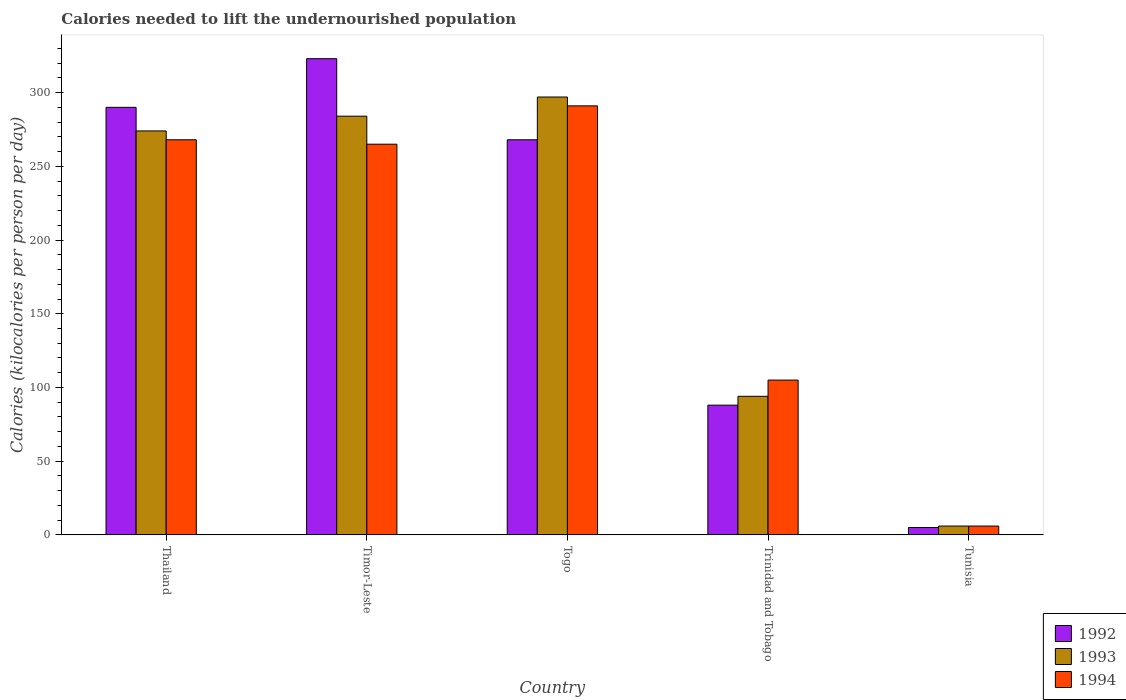How many different coloured bars are there?
Make the answer very short. 3. How many groups of bars are there?
Make the answer very short. 5. Are the number of bars per tick equal to the number of legend labels?
Make the answer very short. Yes. Are the number of bars on each tick of the X-axis equal?
Ensure brevity in your answer.  Yes. How many bars are there on the 5th tick from the right?
Keep it short and to the point. 3. What is the label of the 4th group of bars from the left?
Provide a succinct answer. Trinidad and Tobago. What is the total calories needed to lift the undernourished population in 1993 in Togo?
Give a very brief answer. 297. Across all countries, what is the maximum total calories needed to lift the undernourished population in 1993?
Provide a succinct answer. 297. Across all countries, what is the minimum total calories needed to lift the undernourished population in 1994?
Make the answer very short. 6. In which country was the total calories needed to lift the undernourished population in 1994 maximum?
Your answer should be compact. Togo. In which country was the total calories needed to lift the undernourished population in 1994 minimum?
Ensure brevity in your answer.  Tunisia. What is the total total calories needed to lift the undernourished population in 1993 in the graph?
Keep it short and to the point. 955. What is the difference between the total calories needed to lift the undernourished population in 1992 in Timor-Leste and that in Tunisia?
Your answer should be very brief. 318. What is the average total calories needed to lift the undernourished population in 1994 per country?
Offer a terse response. 187. What is the ratio of the total calories needed to lift the undernourished population in 1994 in Thailand to that in Timor-Leste?
Your answer should be compact. 1.01. Is the difference between the total calories needed to lift the undernourished population in 1992 in Thailand and Togo greater than the difference between the total calories needed to lift the undernourished population in 1993 in Thailand and Togo?
Offer a very short reply. Yes. What is the difference between the highest and the second highest total calories needed to lift the undernourished population in 1992?
Provide a short and direct response. -33. What is the difference between the highest and the lowest total calories needed to lift the undernourished population in 1993?
Ensure brevity in your answer.  291. In how many countries, is the total calories needed to lift the undernourished population in 1992 greater than the average total calories needed to lift the undernourished population in 1992 taken over all countries?
Your response must be concise. 3. Is the sum of the total calories needed to lift the undernourished population in 1993 in Thailand and Tunisia greater than the maximum total calories needed to lift the undernourished population in 1994 across all countries?
Your answer should be compact. No. What does the 3rd bar from the left in Thailand represents?
Offer a terse response. 1994. Is it the case that in every country, the sum of the total calories needed to lift the undernourished population in 1992 and total calories needed to lift the undernourished population in 1994 is greater than the total calories needed to lift the undernourished population in 1993?
Give a very brief answer. Yes. What is the difference between two consecutive major ticks on the Y-axis?
Ensure brevity in your answer.  50. Does the graph contain any zero values?
Your response must be concise. No. Does the graph contain grids?
Offer a very short reply. No. How are the legend labels stacked?
Offer a terse response. Vertical. What is the title of the graph?
Provide a succinct answer. Calories needed to lift the undernourished population. What is the label or title of the X-axis?
Offer a terse response. Country. What is the label or title of the Y-axis?
Make the answer very short. Calories (kilocalories per person per day). What is the Calories (kilocalories per person per day) in 1992 in Thailand?
Give a very brief answer. 290. What is the Calories (kilocalories per person per day) of 1993 in Thailand?
Ensure brevity in your answer.  274. What is the Calories (kilocalories per person per day) in 1994 in Thailand?
Provide a short and direct response. 268. What is the Calories (kilocalories per person per day) of 1992 in Timor-Leste?
Offer a very short reply. 323. What is the Calories (kilocalories per person per day) in 1993 in Timor-Leste?
Offer a very short reply. 284. What is the Calories (kilocalories per person per day) of 1994 in Timor-Leste?
Your response must be concise. 265. What is the Calories (kilocalories per person per day) in 1992 in Togo?
Your response must be concise. 268. What is the Calories (kilocalories per person per day) of 1993 in Togo?
Ensure brevity in your answer.  297. What is the Calories (kilocalories per person per day) in 1994 in Togo?
Keep it short and to the point. 291. What is the Calories (kilocalories per person per day) in 1993 in Trinidad and Tobago?
Ensure brevity in your answer.  94. What is the Calories (kilocalories per person per day) in 1994 in Trinidad and Tobago?
Ensure brevity in your answer.  105. What is the Calories (kilocalories per person per day) in 1992 in Tunisia?
Make the answer very short. 5. What is the Calories (kilocalories per person per day) of 1993 in Tunisia?
Give a very brief answer. 6. What is the Calories (kilocalories per person per day) in 1994 in Tunisia?
Offer a terse response. 6. Across all countries, what is the maximum Calories (kilocalories per person per day) of 1992?
Provide a short and direct response. 323. Across all countries, what is the maximum Calories (kilocalories per person per day) of 1993?
Offer a very short reply. 297. Across all countries, what is the maximum Calories (kilocalories per person per day) of 1994?
Provide a short and direct response. 291. Across all countries, what is the minimum Calories (kilocalories per person per day) of 1992?
Offer a terse response. 5. Across all countries, what is the minimum Calories (kilocalories per person per day) in 1993?
Keep it short and to the point. 6. What is the total Calories (kilocalories per person per day) of 1992 in the graph?
Your response must be concise. 974. What is the total Calories (kilocalories per person per day) of 1993 in the graph?
Offer a terse response. 955. What is the total Calories (kilocalories per person per day) in 1994 in the graph?
Keep it short and to the point. 935. What is the difference between the Calories (kilocalories per person per day) in 1992 in Thailand and that in Timor-Leste?
Keep it short and to the point. -33. What is the difference between the Calories (kilocalories per person per day) in 1992 in Thailand and that in Togo?
Provide a succinct answer. 22. What is the difference between the Calories (kilocalories per person per day) in 1993 in Thailand and that in Togo?
Offer a very short reply. -23. What is the difference between the Calories (kilocalories per person per day) in 1994 in Thailand and that in Togo?
Give a very brief answer. -23. What is the difference between the Calories (kilocalories per person per day) of 1992 in Thailand and that in Trinidad and Tobago?
Your answer should be very brief. 202. What is the difference between the Calories (kilocalories per person per day) in 1993 in Thailand and that in Trinidad and Tobago?
Keep it short and to the point. 180. What is the difference between the Calories (kilocalories per person per day) in 1994 in Thailand and that in Trinidad and Tobago?
Provide a short and direct response. 163. What is the difference between the Calories (kilocalories per person per day) in 1992 in Thailand and that in Tunisia?
Give a very brief answer. 285. What is the difference between the Calories (kilocalories per person per day) in 1993 in Thailand and that in Tunisia?
Your response must be concise. 268. What is the difference between the Calories (kilocalories per person per day) in 1994 in Thailand and that in Tunisia?
Your answer should be very brief. 262. What is the difference between the Calories (kilocalories per person per day) in 1993 in Timor-Leste and that in Togo?
Give a very brief answer. -13. What is the difference between the Calories (kilocalories per person per day) in 1994 in Timor-Leste and that in Togo?
Provide a succinct answer. -26. What is the difference between the Calories (kilocalories per person per day) of 1992 in Timor-Leste and that in Trinidad and Tobago?
Provide a succinct answer. 235. What is the difference between the Calories (kilocalories per person per day) of 1993 in Timor-Leste and that in Trinidad and Tobago?
Your answer should be compact. 190. What is the difference between the Calories (kilocalories per person per day) of 1994 in Timor-Leste and that in Trinidad and Tobago?
Ensure brevity in your answer.  160. What is the difference between the Calories (kilocalories per person per day) in 1992 in Timor-Leste and that in Tunisia?
Provide a succinct answer. 318. What is the difference between the Calories (kilocalories per person per day) of 1993 in Timor-Leste and that in Tunisia?
Provide a succinct answer. 278. What is the difference between the Calories (kilocalories per person per day) in 1994 in Timor-Leste and that in Tunisia?
Your response must be concise. 259. What is the difference between the Calories (kilocalories per person per day) of 1992 in Togo and that in Trinidad and Tobago?
Offer a very short reply. 180. What is the difference between the Calories (kilocalories per person per day) in 1993 in Togo and that in Trinidad and Tobago?
Provide a short and direct response. 203. What is the difference between the Calories (kilocalories per person per day) of 1994 in Togo and that in Trinidad and Tobago?
Your answer should be very brief. 186. What is the difference between the Calories (kilocalories per person per day) in 1992 in Togo and that in Tunisia?
Offer a very short reply. 263. What is the difference between the Calories (kilocalories per person per day) in 1993 in Togo and that in Tunisia?
Keep it short and to the point. 291. What is the difference between the Calories (kilocalories per person per day) of 1994 in Togo and that in Tunisia?
Your answer should be very brief. 285. What is the difference between the Calories (kilocalories per person per day) in 1992 in Trinidad and Tobago and that in Tunisia?
Give a very brief answer. 83. What is the difference between the Calories (kilocalories per person per day) of 1993 in Trinidad and Tobago and that in Tunisia?
Offer a very short reply. 88. What is the difference between the Calories (kilocalories per person per day) in 1994 in Trinidad and Tobago and that in Tunisia?
Give a very brief answer. 99. What is the difference between the Calories (kilocalories per person per day) in 1992 in Thailand and the Calories (kilocalories per person per day) in 1993 in Timor-Leste?
Your response must be concise. 6. What is the difference between the Calories (kilocalories per person per day) in 1993 in Thailand and the Calories (kilocalories per person per day) in 1994 in Timor-Leste?
Keep it short and to the point. 9. What is the difference between the Calories (kilocalories per person per day) of 1992 in Thailand and the Calories (kilocalories per person per day) of 1994 in Togo?
Keep it short and to the point. -1. What is the difference between the Calories (kilocalories per person per day) in 1992 in Thailand and the Calories (kilocalories per person per day) in 1993 in Trinidad and Tobago?
Give a very brief answer. 196. What is the difference between the Calories (kilocalories per person per day) of 1992 in Thailand and the Calories (kilocalories per person per day) of 1994 in Trinidad and Tobago?
Your response must be concise. 185. What is the difference between the Calories (kilocalories per person per day) in 1993 in Thailand and the Calories (kilocalories per person per day) in 1994 in Trinidad and Tobago?
Provide a short and direct response. 169. What is the difference between the Calories (kilocalories per person per day) in 1992 in Thailand and the Calories (kilocalories per person per day) in 1993 in Tunisia?
Ensure brevity in your answer.  284. What is the difference between the Calories (kilocalories per person per day) of 1992 in Thailand and the Calories (kilocalories per person per day) of 1994 in Tunisia?
Keep it short and to the point. 284. What is the difference between the Calories (kilocalories per person per day) in 1993 in Thailand and the Calories (kilocalories per person per day) in 1994 in Tunisia?
Your answer should be compact. 268. What is the difference between the Calories (kilocalories per person per day) of 1992 in Timor-Leste and the Calories (kilocalories per person per day) of 1993 in Togo?
Your answer should be compact. 26. What is the difference between the Calories (kilocalories per person per day) of 1992 in Timor-Leste and the Calories (kilocalories per person per day) of 1994 in Togo?
Your answer should be compact. 32. What is the difference between the Calories (kilocalories per person per day) of 1992 in Timor-Leste and the Calories (kilocalories per person per day) of 1993 in Trinidad and Tobago?
Your response must be concise. 229. What is the difference between the Calories (kilocalories per person per day) of 1992 in Timor-Leste and the Calories (kilocalories per person per day) of 1994 in Trinidad and Tobago?
Offer a very short reply. 218. What is the difference between the Calories (kilocalories per person per day) of 1993 in Timor-Leste and the Calories (kilocalories per person per day) of 1994 in Trinidad and Tobago?
Ensure brevity in your answer.  179. What is the difference between the Calories (kilocalories per person per day) in 1992 in Timor-Leste and the Calories (kilocalories per person per day) in 1993 in Tunisia?
Your response must be concise. 317. What is the difference between the Calories (kilocalories per person per day) of 1992 in Timor-Leste and the Calories (kilocalories per person per day) of 1994 in Tunisia?
Ensure brevity in your answer.  317. What is the difference between the Calories (kilocalories per person per day) of 1993 in Timor-Leste and the Calories (kilocalories per person per day) of 1994 in Tunisia?
Your answer should be compact. 278. What is the difference between the Calories (kilocalories per person per day) of 1992 in Togo and the Calories (kilocalories per person per day) of 1993 in Trinidad and Tobago?
Provide a succinct answer. 174. What is the difference between the Calories (kilocalories per person per day) of 1992 in Togo and the Calories (kilocalories per person per day) of 1994 in Trinidad and Tobago?
Provide a succinct answer. 163. What is the difference between the Calories (kilocalories per person per day) of 1993 in Togo and the Calories (kilocalories per person per day) of 1994 in Trinidad and Tobago?
Offer a very short reply. 192. What is the difference between the Calories (kilocalories per person per day) of 1992 in Togo and the Calories (kilocalories per person per day) of 1993 in Tunisia?
Provide a succinct answer. 262. What is the difference between the Calories (kilocalories per person per day) in 1992 in Togo and the Calories (kilocalories per person per day) in 1994 in Tunisia?
Make the answer very short. 262. What is the difference between the Calories (kilocalories per person per day) in 1993 in Togo and the Calories (kilocalories per person per day) in 1994 in Tunisia?
Your answer should be compact. 291. What is the difference between the Calories (kilocalories per person per day) of 1992 in Trinidad and Tobago and the Calories (kilocalories per person per day) of 1993 in Tunisia?
Make the answer very short. 82. What is the difference between the Calories (kilocalories per person per day) in 1993 in Trinidad and Tobago and the Calories (kilocalories per person per day) in 1994 in Tunisia?
Your answer should be very brief. 88. What is the average Calories (kilocalories per person per day) of 1992 per country?
Provide a short and direct response. 194.8. What is the average Calories (kilocalories per person per day) of 1993 per country?
Provide a short and direct response. 191. What is the average Calories (kilocalories per person per day) of 1994 per country?
Provide a short and direct response. 187. What is the difference between the Calories (kilocalories per person per day) in 1993 and Calories (kilocalories per person per day) in 1994 in Thailand?
Keep it short and to the point. 6. What is the difference between the Calories (kilocalories per person per day) of 1992 and Calories (kilocalories per person per day) of 1993 in Timor-Leste?
Provide a succinct answer. 39. What is the difference between the Calories (kilocalories per person per day) in 1993 and Calories (kilocalories per person per day) in 1994 in Trinidad and Tobago?
Provide a short and direct response. -11. What is the difference between the Calories (kilocalories per person per day) in 1993 and Calories (kilocalories per person per day) in 1994 in Tunisia?
Provide a succinct answer. 0. What is the ratio of the Calories (kilocalories per person per day) in 1992 in Thailand to that in Timor-Leste?
Your response must be concise. 0.9. What is the ratio of the Calories (kilocalories per person per day) in 1993 in Thailand to that in Timor-Leste?
Ensure brevity in your answer.  0.96. What is the ratio of the Calories (kilocalories per person per day) of 1994 in Thailand to that in Timor-Leste?
Provide a short and direct response. 1.01. What is the ratio of the Calories (kilocalories per person per day) in 1992 in Thailand to that in Togo?
Provide a succinct answer. 1.08. What is the ratio of the Calories (kilocalories per person per day) in 1993 in Thailand to that in Togo?
Provide a succinct answer. 0.92. What is the ratio of the Calories (kilocalories per person per day) in 1994 in Thailand to that in Togo?
Ensure brevity in your answer.  0.92. What is the ratio of the Calories (kilocalories per person per day) of 1992 in Thailand to that in Trinidad and Tobago?
Your response must be concise. 3.3. What is the ratio of the Calories (kilocalories per person per day) of 1993 in Thailand to that in Trinidad and Tobago?
Your response must be concise. 2.91. What is the ratio of the Calories (kilocalories per person per day) of 1994 in Thailand to that in Trinidad and Tobago?
Provide a short and direct response. 2.55. What is the ratio of the Calories (kilocalories per person per day) of 1993 in Thailand to that in Tunisia?
Offer a very short reply. 45.67. What is the ratio of the Calories (kilocalories per person per day) in 1994 in Thailand to that in Tunisia?
Keep it short and to the point. 44.67. What is the ratio of the Calories (kilocalories per person per day) in 1992 in Timor-Leste to that in Togo?
Your response must be concise. 1.21. What is the ratio of the Calories (kilocalories per person per day) of 1993 in Timor-Leste to that in Togo?
Keep it short and to the point. 0.96. What is the ratio of the Calories (kilocalories per person per day) in 1994 in Timor-Leste to that in Togo?
Ensure brevity in your answer.  0.91. What is the ratio of the Calories (kilocalories per person per day) in 1992 in Timor-Leste to that in Trinidad and Tobago?
Ensure brevity in your answer.  3.67. What is the ratio of the Calories (kilocalories per person per day) of 1993 in Timor-Leste to that in Trinidad and Tobago?
Keep it short and to the point. 3.02. What is the ratio of the Calories (kilocalories per person per day) of 1994 in Timor-Leste to that in Trinidad and Tobago?
Keep it short and to the point. 2.52. What is the ratio of the Calories (kilocalories per person per day) in 1992 in Timor-Leste to that in Tunisia?
Provide a succinct answer. 64.6. What is the ratio of the Calories (kilocalories per person per day) of 1993 in Timor-Leste to that in Tunisia?
Provide a short and direct response. 47.33. What is the ratio of the Calories (kilocalories per person per day) of 1994 in Timor-Leste to that in Tunisia?
Provide a short and direct response. 44.17. What is the ratio of the Calories (kilocalories per person per day) of 1992 in Togo to that in Trinidad and Tobago?
Your response must be concise. 3.05. What is the ratio of the Calories (kilocalories per person per day) in 1993 in Togo to that in Trinidad and Tobago?
Your answer should be compact. 3.16. What is the ratio of the Calories (kilocalories per person per day) of 1994 in Togo to that in Trinidad and Tobago?
Keep it short and to the point. 2.77. What is the ratio of the Calories (kilocalories per person per day) of 1992 in Togo to that in Tunisia?
Provide a short and direct response. 53.6. What is the ratio of the Calories (kilocalories per person per day) of 1993 in Togo to that in Tunisia?
Offer a terse response. 49.5. What is the ratio of the Calories (kilocalories per person per day) of 1994 in Togo to that in Tunisia?
Provide a short and direct response. 48.5. What is the ratio of the Calories (kilocalories per person per day) of 1993 in Trinidad and Tobago to that in Tunisia?
Your response must be concise. 15.67. What is the difference between the highest and the lowest Calories (kilocalories per person per day) in 1992?
Keep it short and to the point. 318. What is the difference between the highest and the lowest Calories (kilocalories per person per day) in 1993?
Keep it short and to the point. 291. What is the difference between the highest and the lowest Calories (kilocalories per person per day) in 1994?
Offer a terse response. 285. 